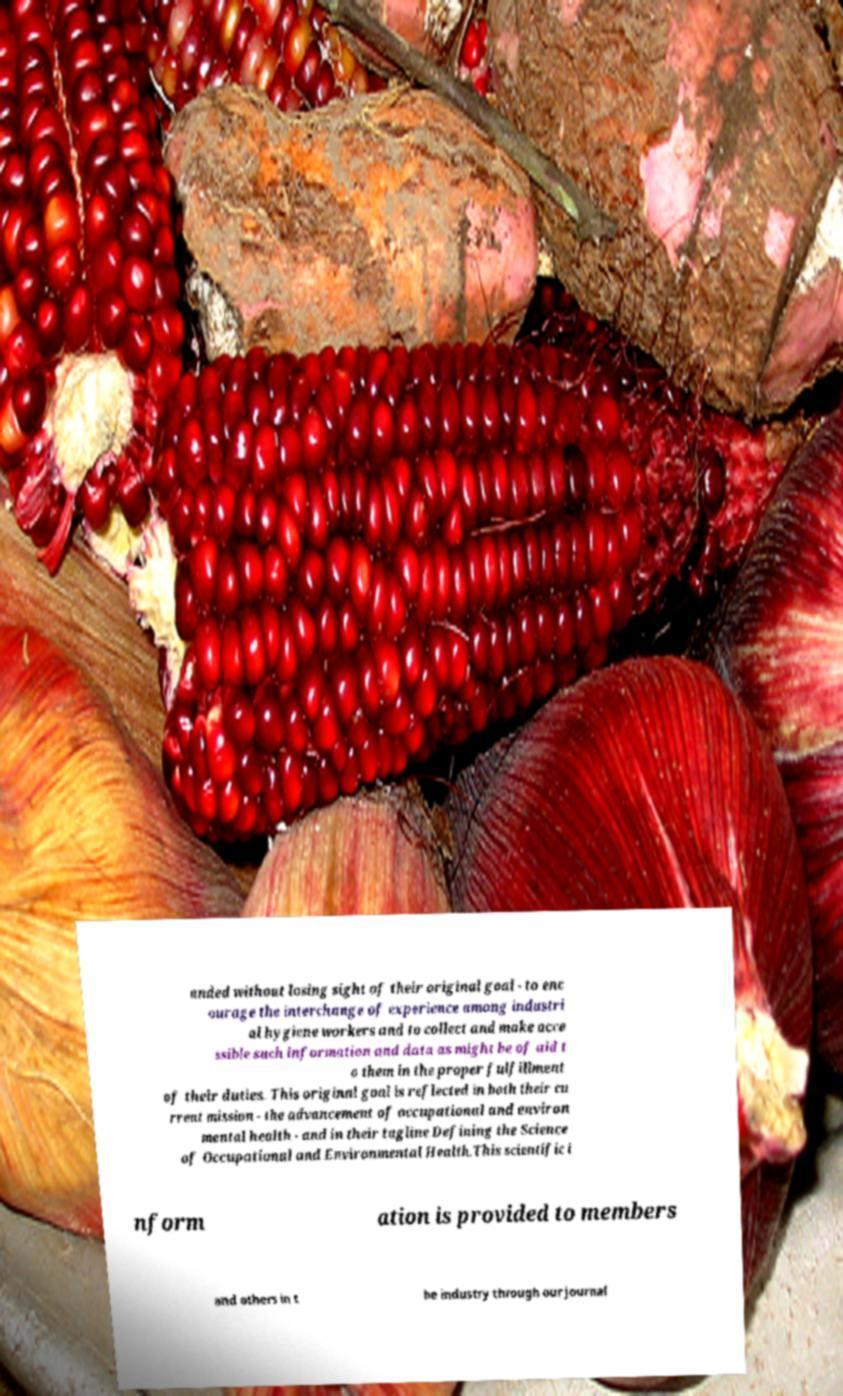Can you read and provide the text displayed in the image?This photo seems to have some interesting text. Can you extract and type it out for me? anded without losing sight of their original goal - to enc ourage the interchange of experience among industri al hygiene workers and to collect and make acce ssible such information and data as might be of aid t o them in the proper fulfillment of their duties. This original goal is reflected in both their cu rrent mission - the advancement of occupational and environ mental health - and in their tagline Defining the Science of Occupational and Environmental Health.This scientific i nform ation is provided to members and others in t he industry through our journal 